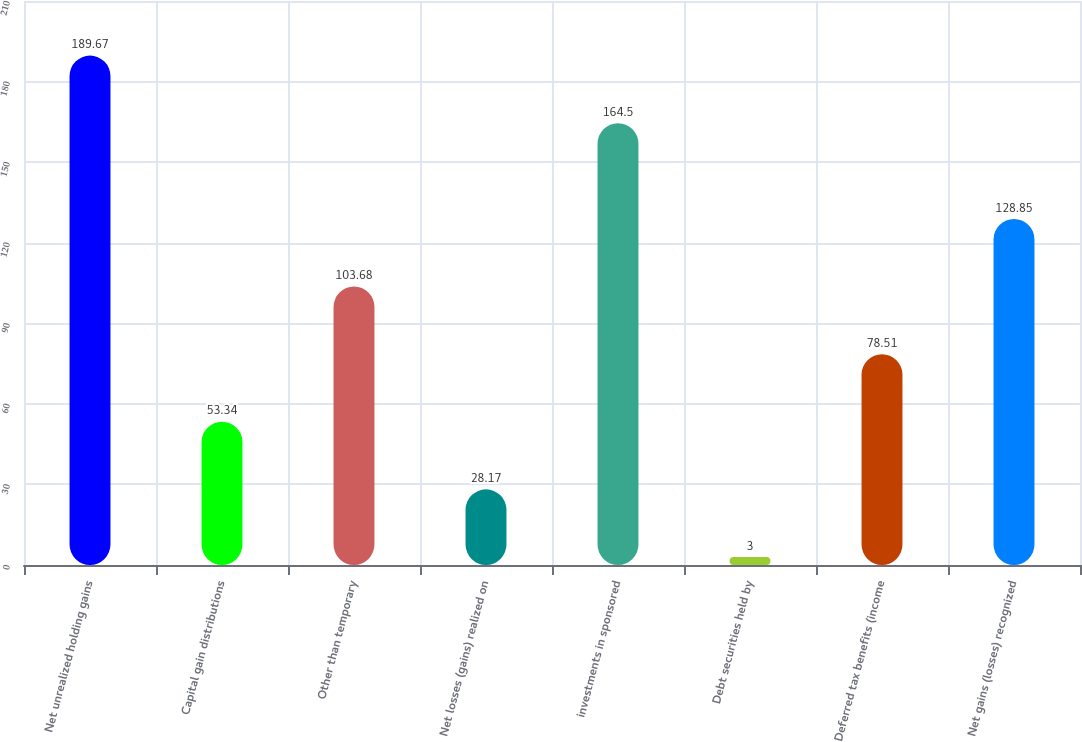Convert chart. <chart><loc_0><loc_0><loc_500><loc_500><bar_chart><fcel>Net unrealized holding gains<fcel>Capital gain distributions<fcel>Other than temporary<fcel>Net losses (gains) realized on<fcel>investments in sponsored<fcel>Debt securities held by<fcel>Deferred tax benefits (income<fcel>Net gains (losses) recognized<nl><fcel>189.67<fcel>53.34<fcel>103.68<fcel>28.17<fcel>164.5<fcel>3<fcel>78.51<fcel>128.85<nl></chart> 